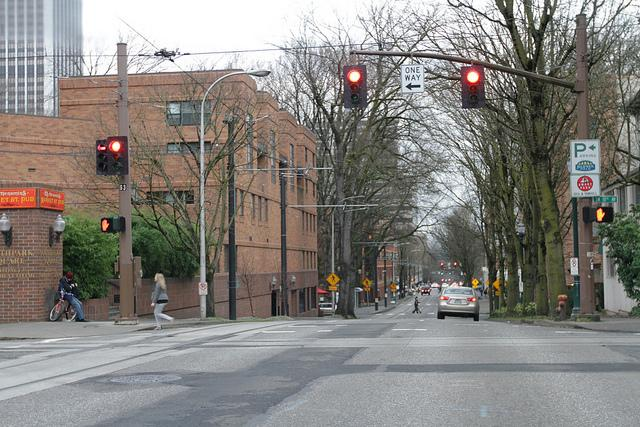Where do you think this is located? city 